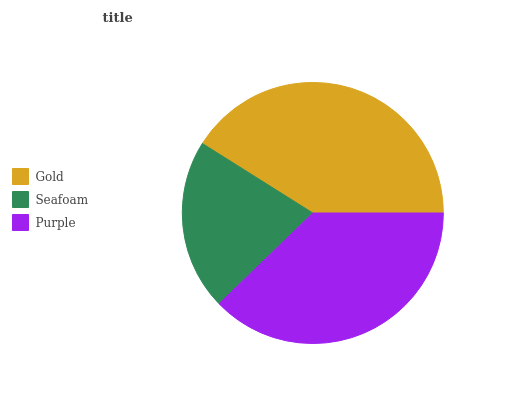Is Seafoam the minimum?
Answer yes or no. Yes. Is Gold the maximum?
Answer yes or no. Yes. Is Purple the minimum?
Answer yes or no. No. Is Purple the maximum?
Answer yes or no. No. Is Purple greater than Seafoam?
Answer yes or no. Yes. Is Seafoam less than Purple?
Answer yes or no. Yes. Is Seafoam greater than Purple?
Answer yes or no. No. Is Purple less than Seafoam?
Answer yes or no. No. Is Purple the high median?
Answer yes or no. Yes. Is Purple the low median?
Answer yes or no. Yes. Is Seafoam the high median?
Answer yes or no. No. Is Gold the low median?
Answer yes or no. No. 